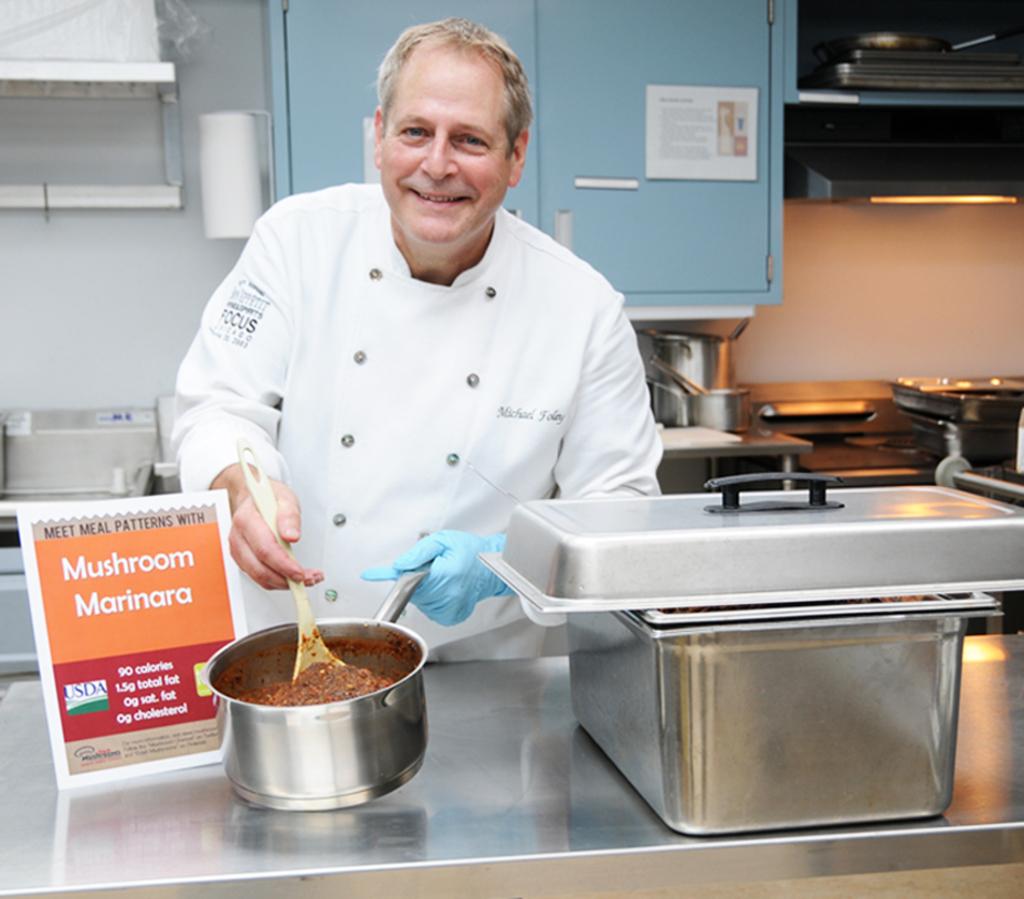What is the chef cooking?
Keep it short and to the point. Mushroom marinara. How many calories in this dish?
Provide a short and direct response. 90. 